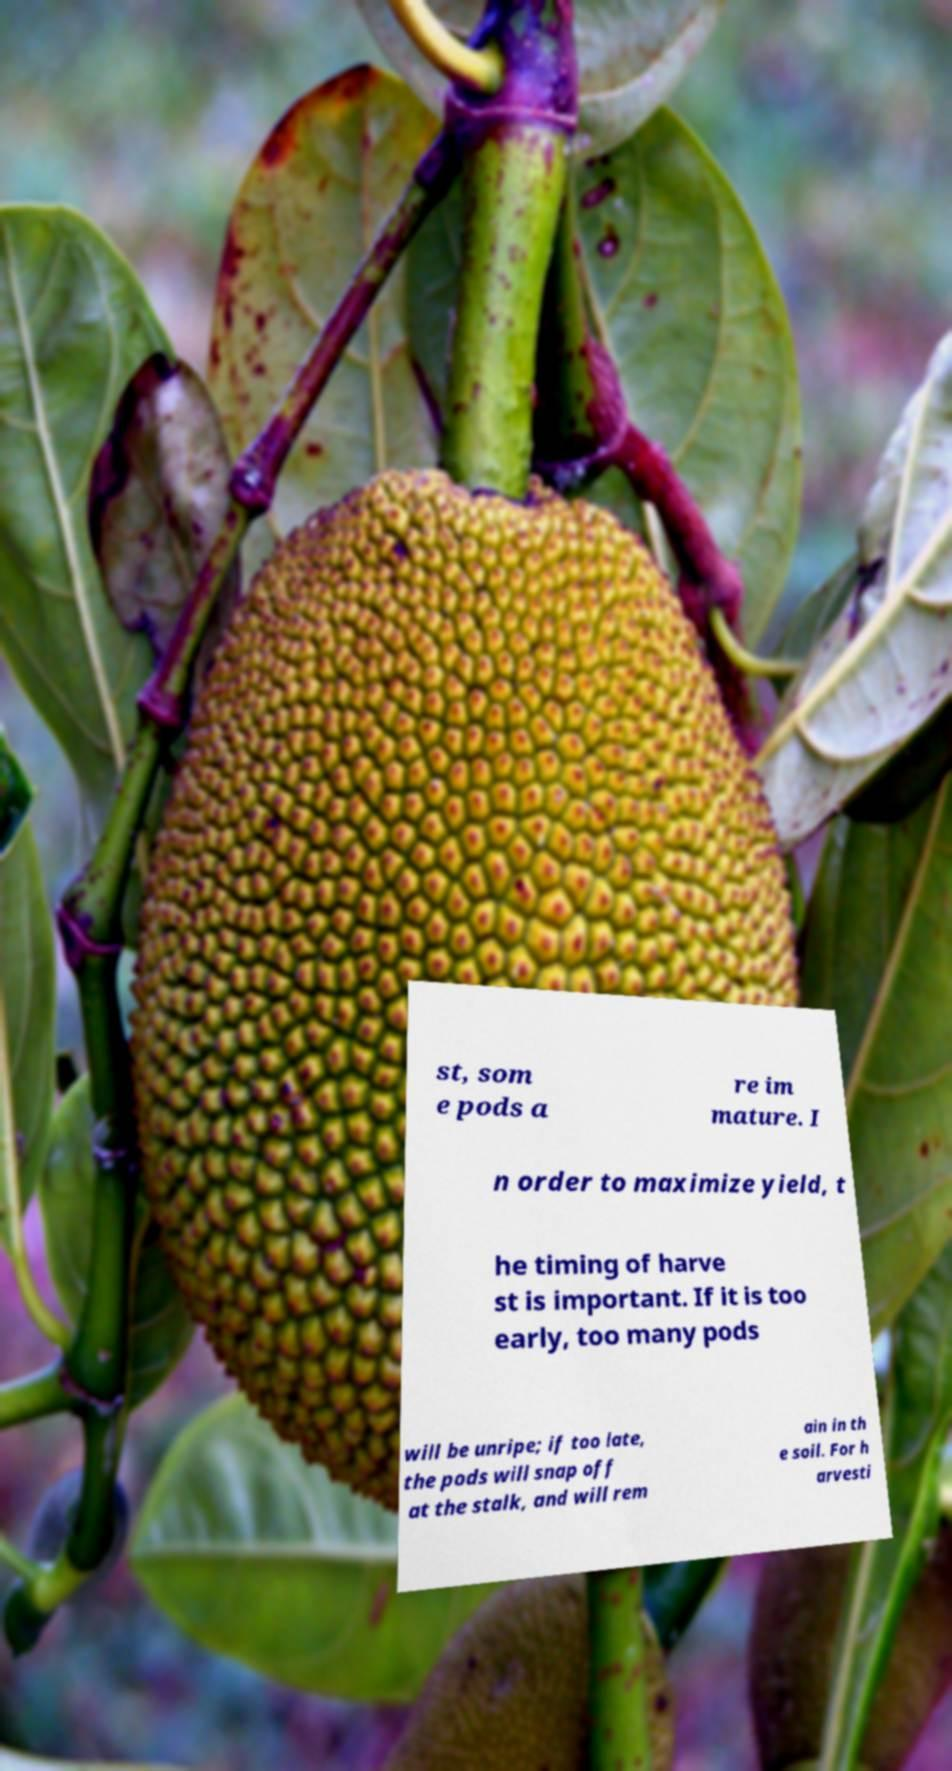Could you extract and type out the text from this image? st, som e pods a re im mature. I n order to maximize yield, t he timing of harve st is important. If it is too early, too many pods will be unripe; if too late, the pods will snap off at the stalk, and will rem ain in th e soil. For h arvesti 